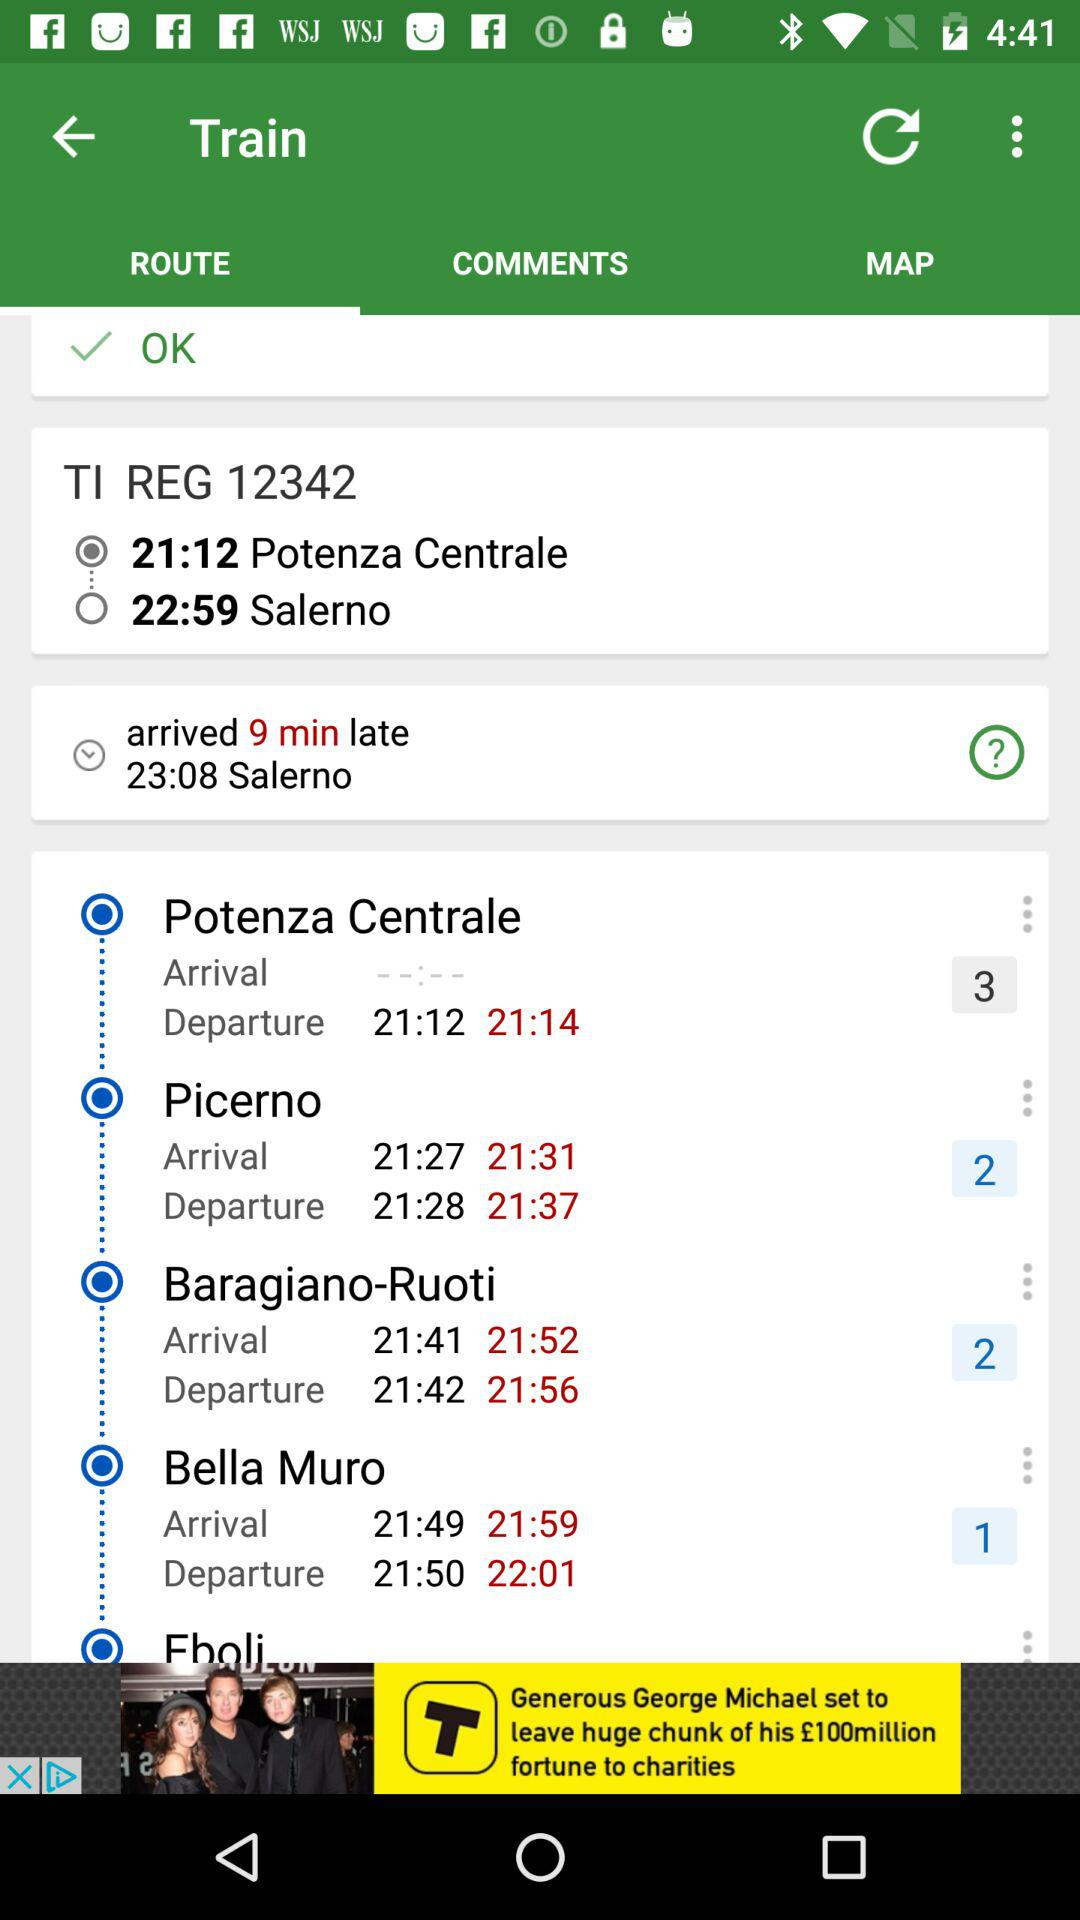What is the train number? The train number is 12342. 